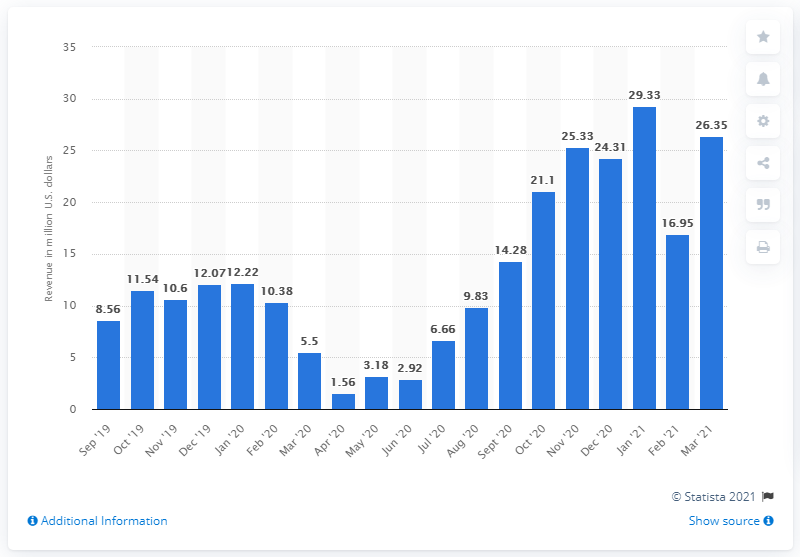List a handful of essential elements in this visual. According to the data collected in March 2021, the state of Indiana generated approximately $26.35 million in revenue from sports betting. In the previous month, the total revenue generated from sports betting was 16.95. 